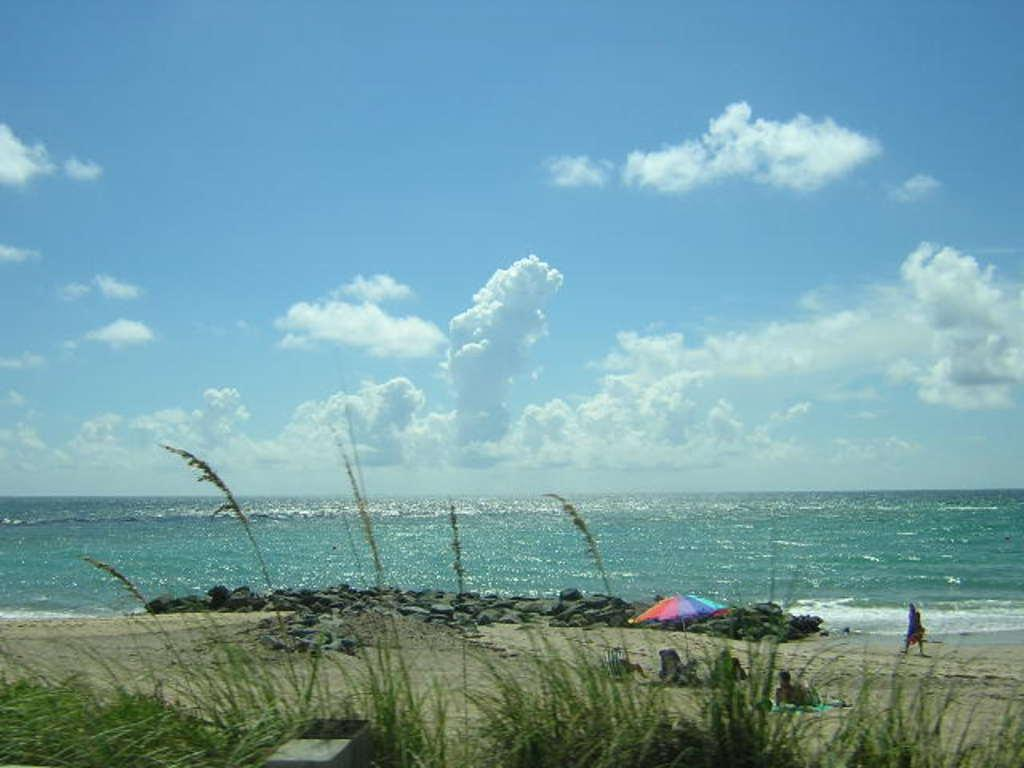What is the location of the picture? The picture is taken near a shore. What can be seen in the foreground of the image? There are plants, soil, stones, and people in the foreground of the image. What is the main feature in the center of the image? There is a water body in the center of the image. How is the weather in the image? The sky is sunny in the image. What type of oil can be seen floating on the water in the image? There is no oil present in the image; it is a water body with no visible contaminants. How many balloons are being held by the people in the image? There are no balloons visible in the image; the people are not holding any. 